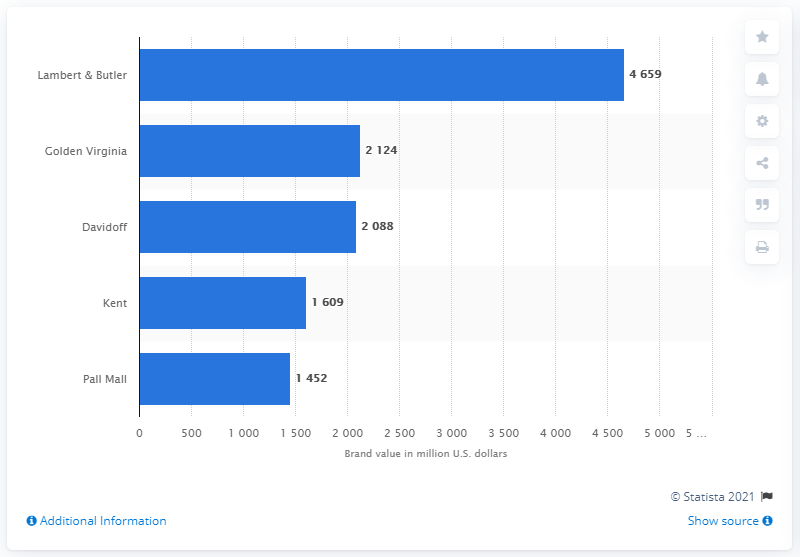Indicate a few pertinent items in this graphic. The net worth of Lambert & Butler was 4,659. In 2015, the most valuable tobacco brand in the UK was Lambert & Butler. In the year 2015, Golden Virginia was the second most popular tobacco brand in the United Kingdom. 